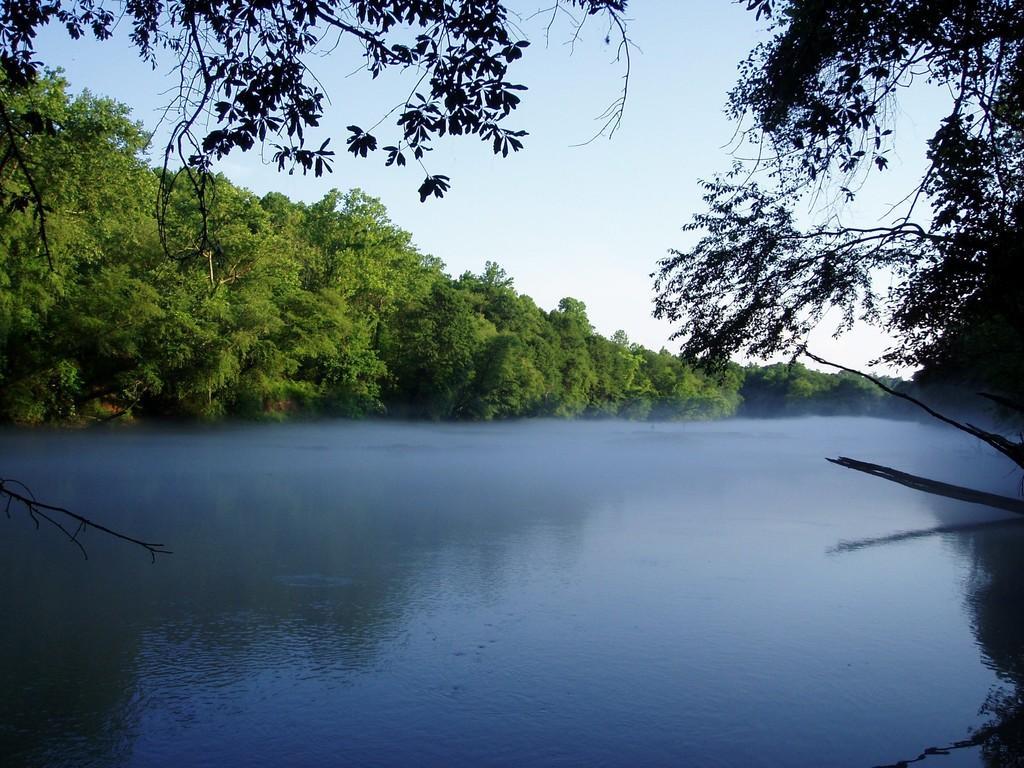Can you describe this image briefly? We can see water and trees. In the background we can see sky. 